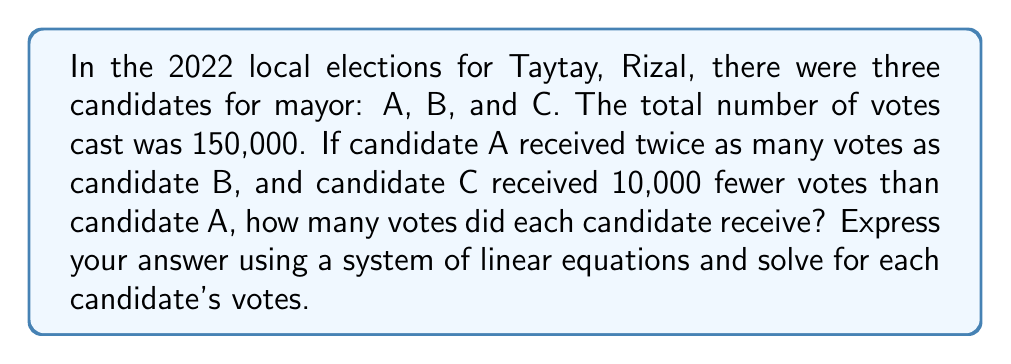What is the answer to this math problem? Let's approach this step-by-step:

1) Let's define our variables:
   $x$ = number of votes for candidate B
   $2x$ = number of votes for candidate A (since A received twice as many as B)
   $2x - 10000$ = number of votes for candidate C (10,000 fewer than A)

2) We can now set up an equation based on the total number of votes:
   $x + 2x + (2x - 10000) = 150000$

3) Simplify the left side of the equation:
   $5x - 10000 = 150000$

4) Add 10000 to both sides:
   $5x = 160000$

5) Divide both sides by 5:
   $x = 32000$

6) Now that we know $x$, we can calculate the votes for each candidate:
   Candidate B: $x = 32000$
   Candidate A: $2x = 2(32000) = 64000$
   Candidate C: $2x - 10000 = 64000 - 10000 = 54000$

7) We can verify that the total adds up to 150,000:
   $32000 + 64000 + 54000 = 150000$

Therefore, the distribution of votes can be expressed as:
$$\begin{cases}
A = 2x \\
B = x \\
C = 2x - 10000 \\
x + 2x + (2x - 10000) = 150000
\end{cases}$$

Where $x = 32000$, $A = 64000$, $B = 32000$, and $C = 54000$.
Answer: $A = 64000$, $B = 32000$, $C = 54000$ 